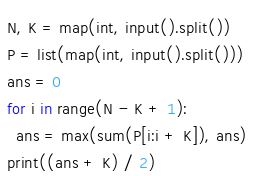<code> <loc_0><loc_0><loc_500><loc_500><_Python_>N, K = map(int, input().split())
P = list(map(int, input().split()))
ans = 0
for i in range(N - K + 1):
  ans = max(sum(P[i:i + K]), ans)
print((ans + K) / 2)</code> 